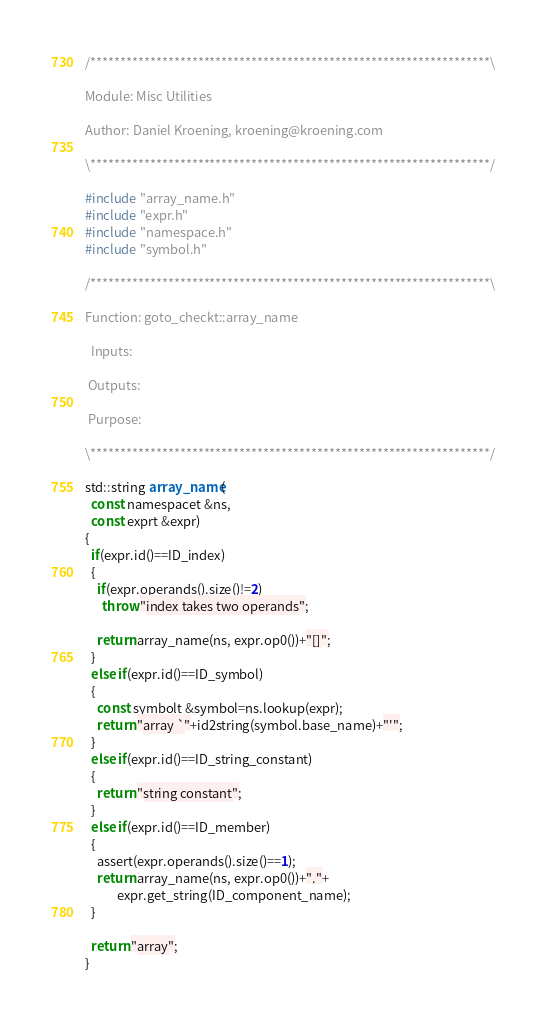<code> <loc_0><loc_0><loc_500><loc_500><_C++_>/*******************************************************************\

Module: Misc Utilities

Author: Daniel Kroening, kroening@kroening.com

\*******************************************************************/

#include "array_name.h"
#include "expr.h"
#include "namespace.h"
#include "symbol.h"

/*******************************************************************\

Function: goto_checkt::array_name

  Inputs:

 Outputs:

 Purpose:

\*******************************************************************/

std::string array_name(
  const namespacet &ns,
  const exprt &expr)
{
  if(expr.id()==ID_index)
  {
    if(expr.operands().size()!=2)
      throw "index takes two operands";

    return array_name(ns, expr.op0())+"[]";
  }
  else if(expr.id()==ID_symbol)
  {
    const symbolt &symbol=ns.lookup(expr);
    return "array `"+id2string(symbol.base_name)+"'";
  }
  else if(expr.id()==ID_string_constant)
  {
    return "string constant";
  }
  else if(expr.id()==ID_member)
  {
    assert(expr.operands().size()==1);
    return array_name(ns, expr.op0())+"."+
           expr.get_string(ID_component_name);
  }

  return "array";
}

</code> 